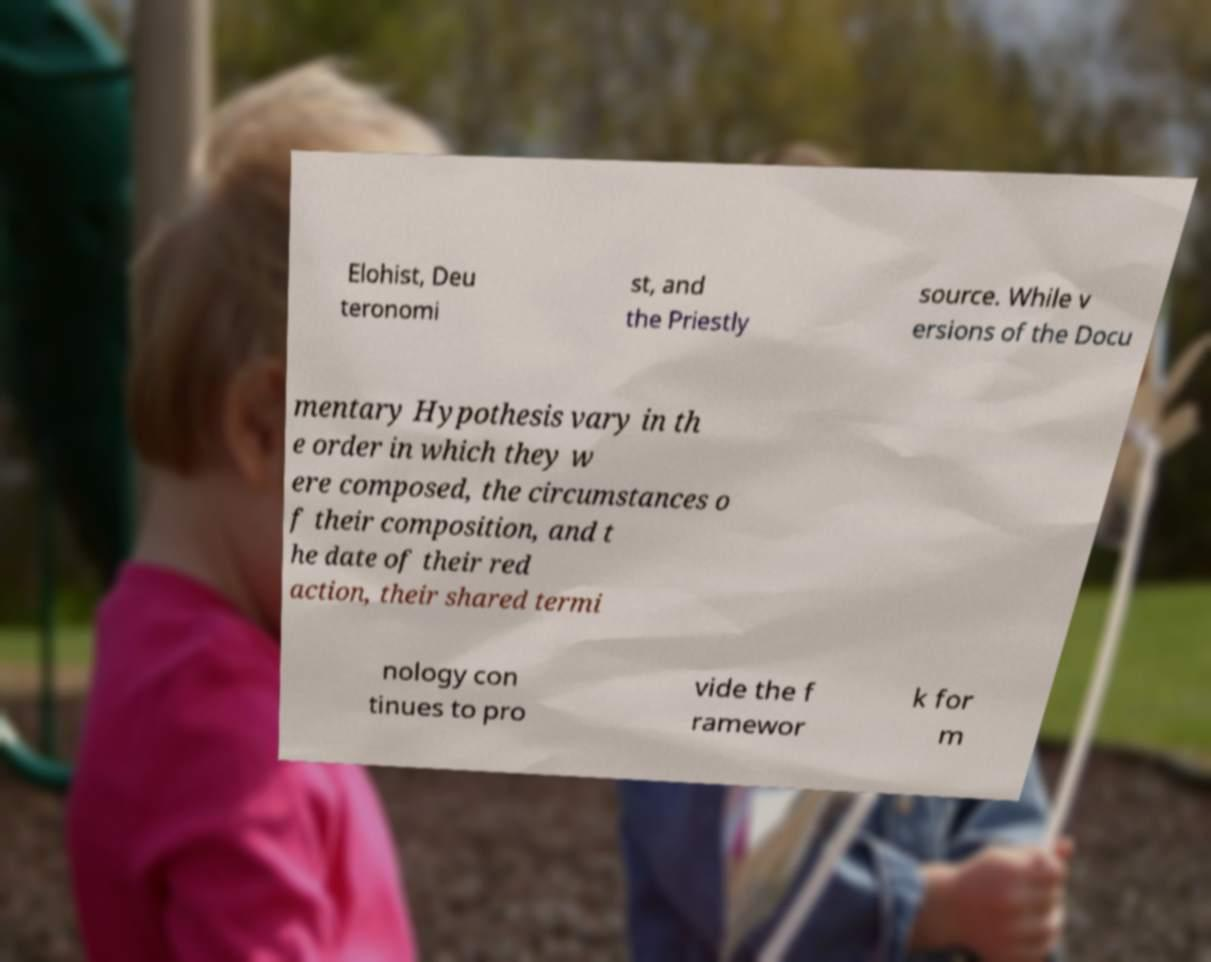Can you read and provide the text displayed in the image?This photo seems to have some interesting text. Can you extract and type it out for me? Elohist, Deu teronomi st, and the Priestly source. While v ersions of the Docu mentary Hypothesis vary in th e order in which they w ere composed, the circumstances o f their composition, and t he date of their red action, their shared termi nology con tinues to pro vide the f ramewor k for m 